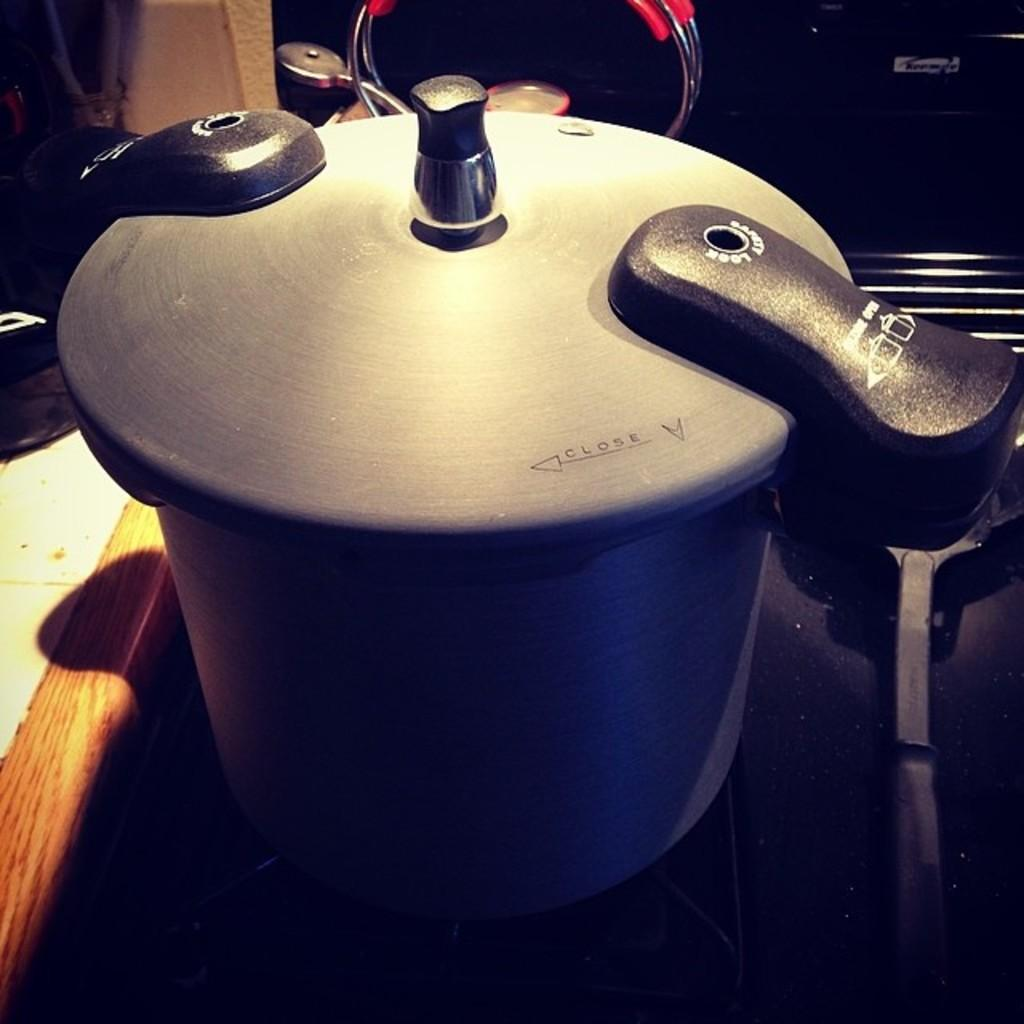<image>
Relay a brief, clear account of the picture shown. The lid of a pot has to be turned clockwise in order to close correctly. 